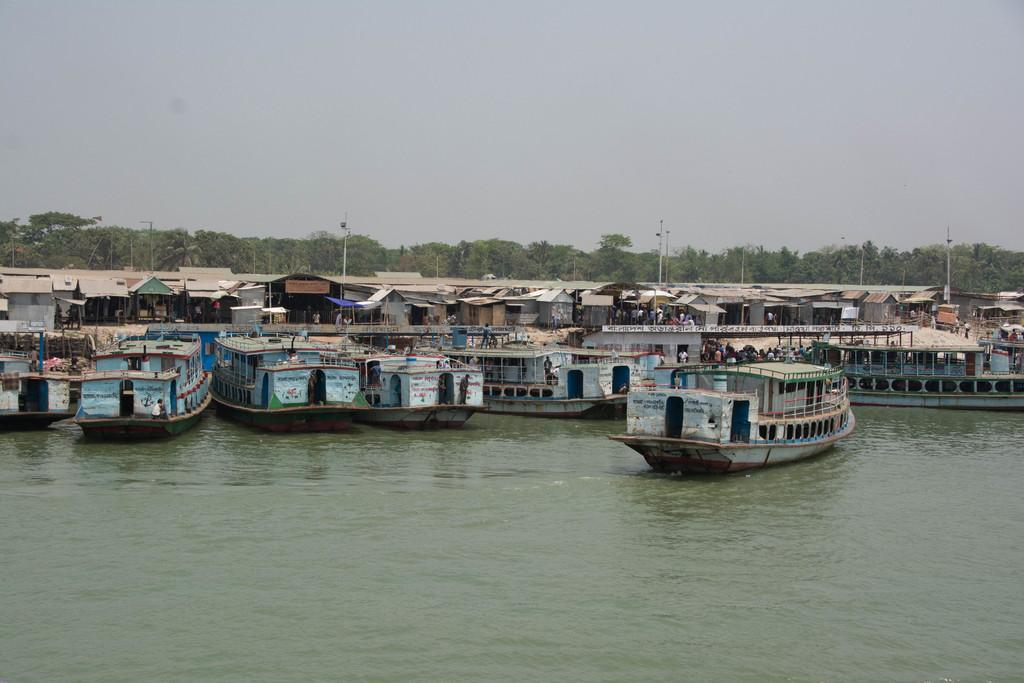What is in the water in the image? There are boats in the water in the image. What can be seen in the background of the image? There are houses, poles, and trees visible in the background. What type of bone is being used as a leg for one of the boats in the image? There is no bone or leg present in the image; the boats are floating on the water. 